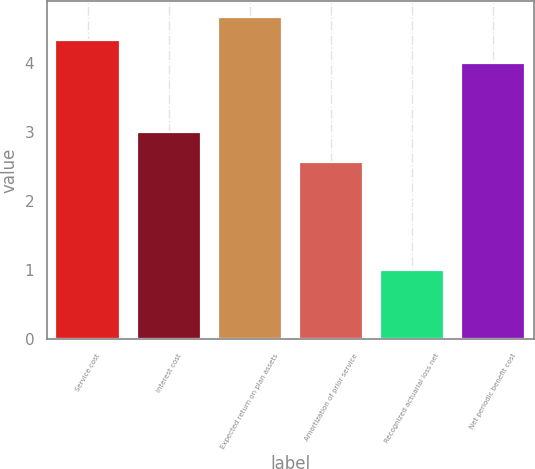Convert chart to OTSL. <chart><loc_0><loc_0><loc_500><loc_500><bar_chart><fcel>Service cost<fcel>Interest cost<fcel>Expected return on plan assets<fcel>Amortization of prior service<fcel>Recognized actuarial loss net<fcel>Net periodic benefit cost<nl><fcel>4.33<fcel>3<fcel>4.66<fcel>2.57<fcel>1<fcel>4<nl></chart> 